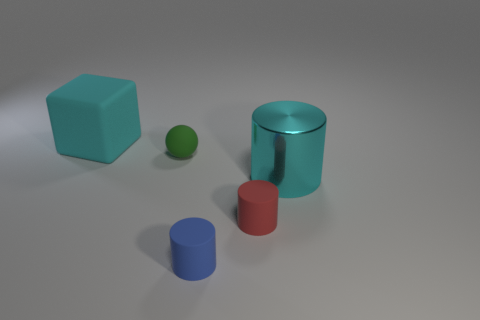Subtract 1 cylinders. How many cylinders are left? 2 Add 5 small red cylinders. How many objects exist? 10 Subtract all blocks. How many objects are left? 4 Subtract 1 blue cylinders. How many objects are left? 4 Subtract all blue things. Subtract all cubes. How many objects are left? 3 Add 1 cyan objects. How many cyan objects are left? 3 Add 2 green matte spheres. How many green matte spheres exist? 3 